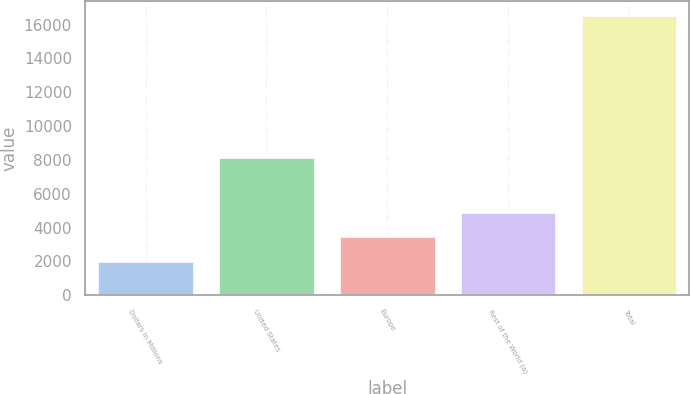Convert chart. <chart><loc_0><loc_0><loc_500><loc_500><bar_chart><fcel>Dollars in Millions<fcel>United States<fcel>Europe<fcel>Rest of the World (a)<fcel>Total<nl><fcel>2015<fcel>8188<fcel>3491<fcel>4945.5<fcel>16560<nl></chart> 